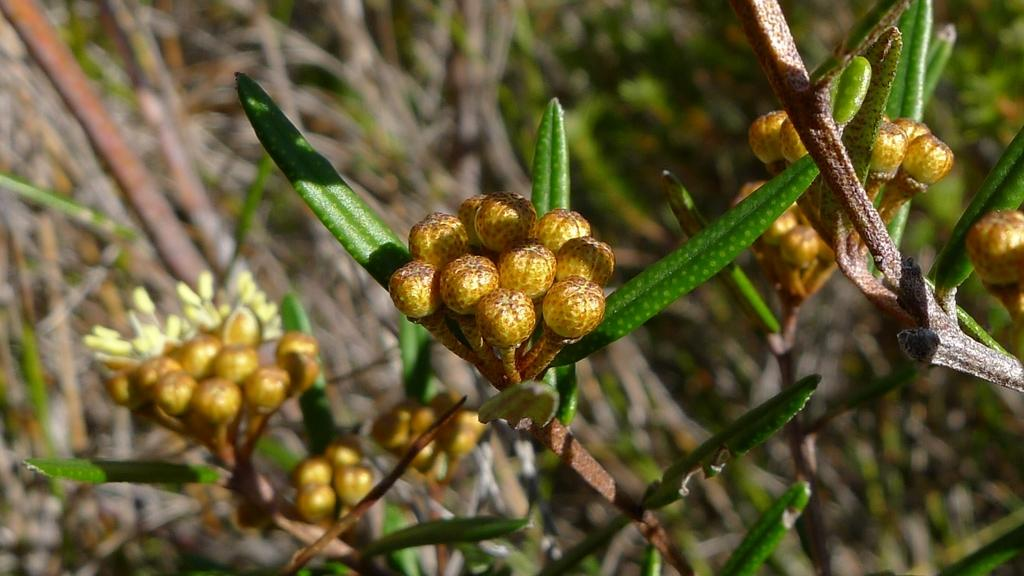What type of living organisms can be seen in the image? The image contains plants. Can you describe the specific parts of the plant that are visible in the foreground? There are buds and stems of a plant in the foreground of the image. How would you describe the background of the image? The background of the image is blurred. How many kittens are playing with the bean in the image? There are no kittens or beans present in the image. What achievements has the achiever in the image accomplished? There is no achiever or any indication of achievements in the image. 